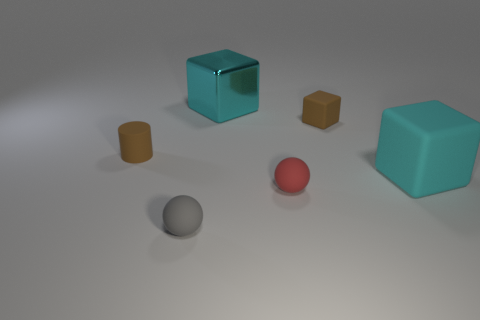Add 4 red spheres. How many objects exist? 10 Subtract all big metal cubes. How many cubes are left? 2 Subtract all purple spheres. How many cyan blocks are left? 2 Subtract all cylinders. How many objects are left? 5 Subtract 1 balls. How many balls are left? 1 Subtract all cyan blocks. How many blocks are left? 1 Add 1 rubber cylinders. How many rubber cylinders are left? 2 Add 1 rubber blocks. How many rubber blocks exist? 3 Subtract 0 blue spheres. How many objects are left? 6 Subtract all purple cylinders. Subtract all cyan blocks. How many cylinders are left? 1 